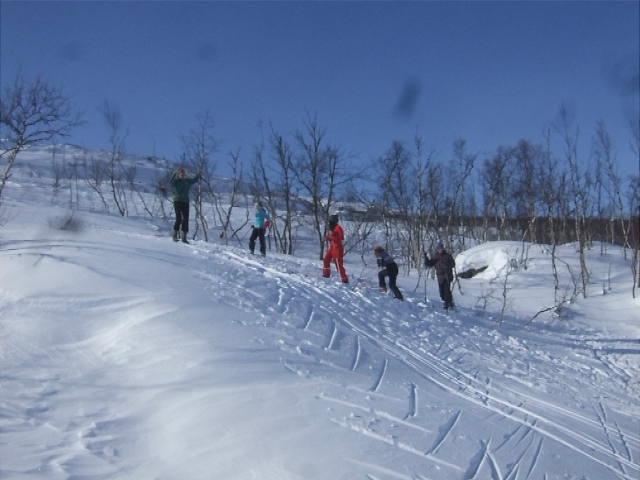Who is the man in red trying to reach?

Choices:
A) green jacket
B) red pants
C) grey jacket
D) pink jacket green jacket 